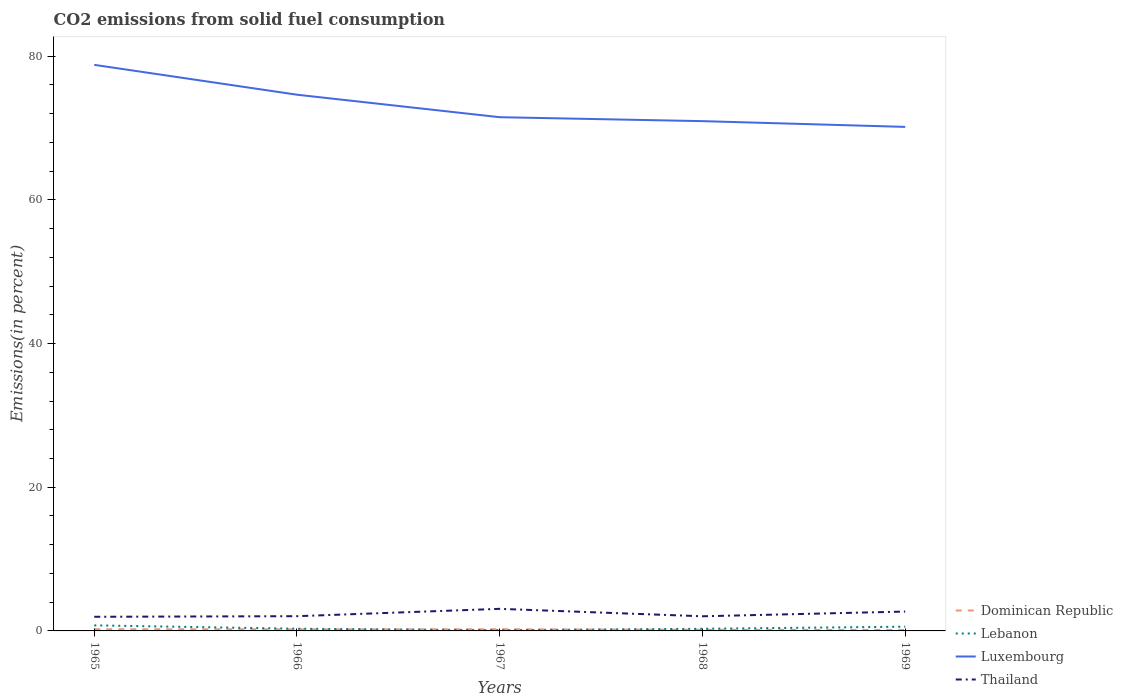How many different coloured lines are there?
Your answer should be compact. 4. Does the line corresponding to Dominican Republic intersect with the line corresponding to Luxembourg?
Make the answer very short. No. Is the number of lines equal to the number of legend labels?
Provide a succinct answer. Yes. Across all years, what is the maximum total CO2 emitted in Lebanon?
Keep it short and to the point. 0.1. In which year was the total CO2 emitted in Luxembourg maximum?
Give a very brief answer. 1969. What is the total total CO2 emitted in Dominican Republic in the graph?
Your answer should be compact. 0.08. What is the difference between the highest and the second highest total CO2 emitted in Dominican Republic?
Your answer should be compact. 0.1. What is the difference between the highest and the lowest total CO2 emitted in Thailand?
Provide a short and direct response. 2. Is the total CO2 emitted in Lebanon strictly greater than the total CO2 emitted in Luxembourg over the years?
Keep it short and to the point. Yes. How many years are there in the graph?
Provide a succinct answer. 5. Does the graph contain any zero values?
Offer a terse response. No. Does the graph contain grids?
Keep it short and to the point. No. Where does the legend appear in the graph?
Offer a very short reply. Bottom right. How are the legend labels stacked?
Ensure brevity in your answer.  Vertical. What is the title of the graph?
Your response must be concise. CO2 emissions from solid fuel consumption. What is the label or title of the X-axis?
Provide a succinct answer. Years. What is the label or title of the Y-axis?
Provide a succinct answer. Emissions(in percent). What is the Emissions(in percent) of Dominican Republic in 1965?
Make the answer very short. 0.24. What is the Emissions(in percent) of Lebanon in 1965?
Give a very brief answer. 0.77. What is the Emissions(in percent) of Luxembourg in 1965?
Keep it short and to the point. 78.79. What is the Emissions(in percent) in Thailand in 1965?
Provide a succinct answer. 1.97. What is the Emissions(in percent) of Dominican Republic in 1966?
Offer a very short reply. 0.22. What is the Emissions(in percent) of Lebanon in 1966?
Your answer should be very brief. 0.3. What is the Emissions(in percent) of Luxembourg in 1966?
Your answer should be compact. 74.63. What is the Emissions(in percent) in Thailand in 1966?
Your answer should be very brief. 2.05. What is the Emissions(in percent) of Dominican Republic in 1967?
Provide a succinct answer. 0.23. What is the Emissions(in percent) in Lebanon in 1967?
Your response must be concise. 0.1. What is the Emissions(in percent) of Luxembourg in 1967?
Offer a very short reply. 71.5. What is the Emissions(in percent) of Thailand in 1967?
Offer a very short reply. 3.07. What is the Emissions(in percent) in Dominican Republic in 1968?
Your response must be concise. 0.16. What is the Emissions(in percent) of Lebanon in 1968?
Make the answer very short. 0.3. What is the Emissions(in percent) in Luxembourg in 1968?
Offer a terse response. 70.95. What is the Emissions(in percent) of Thailand in 1968?
Provide a short and direct response. 2.04. What is the Emissions(in percent) of Dominican Republic in 1969?
Give a very brief answer. 0.14. What is the Emissions(in percent) in Lebanon in 1969?
Your answer should be very brief. 0.59. What is the Emissions(in percent) in Luxembourg in 1969?
Provide a succinct answer. 70.15. What is the Emissions(in percent) in Thailand in 1969?
Provide a succinct answer. 2.69. Across all years, what is the maximum Emissions(in percent) of Dominican Republic?
Your answer should be very brief. 0.24. Across all years, what is the maximum Emissions(in percent) of Lebanon?
Give a very brief answer. 0.77. Across all years, what is the maximum Emissions(in percent) in Luxembourg?
Make the answer very short. 78.79. Across all years, what is the maximum Emissions(in percent) in Thailand?
Offer a very short reply. 3.07. Across all years, what is the minimum Emissions(in percent) in Dominican Republic?
Your answer should be compact. 0.14. Across all years, what is the minimum Emissions(in percent) in Lebanon?
Ensure brevity in your answer.  0.1. Across all years, what is the minimum Emissions(in percent) of Luxembourg?
Your response must be concise. 70.15. Across all years, what is the minimum Emissions(in percent) of Thailand?
Provide a short and direct response. 1.97. What is the total Emissions(in percent) in Dominican Republic in the graph?
Provide a succinct answer. 0.98. What is the total Emissions(in percent) in Lebanon in the graph?
Your response must be concise. 2.07. What is the total Emissions(in percent) in Luxembourg in the graph?
Your answer should be compact. 366.01. What is the total Emissions(in percent) of Thailand in the graph?
Provide a short and direct response. 11.82. What is the difference between the Emissions(in percent) of Dominican Republic in 1965 and that in 1966?
Your response must be concise. 0.02. What is the difference between the Emissions(in percent) of Lebanon in 1965 and that in 1966?
Give a very brief answer. 0.47. What is the difference between the Emissions(in percent) in Luxembourg in 1965 and that in 1966?
Provide a succinct answer. 4.16. What is the difference between the Emissions(in percent) in Thailand in 1965 and that in 1966?
Ensure brevity in your answer.  -0.08. What is the difference between the Emissions(in percent) of Dominican Republic in 1965 and that in 1967?
Offer a very short reply. 0. What is the difference between the Emissions(in percent) in Lebanon in 1965 and that in 1967?
Provide a short and direct response. 0.67. What is the difference between the Emissions(in percent) of Luxembourg in 1965 and that in 1967?
Offer a terse response. 7.29. What is the difference between the Emissions(in percent) of Thailand in 1965 and that in 1967?
Give a very brief answer. -1.11. What is the difference between the Emissions(in percent) in Dominican Republic in 1965 and that in 1968?
Ensure brevity in your answer.  0.08. What is the difference between the Emissions(in percent) of Lebanon in 1965 and that in 1968?
Give a very brief answer. 0.48. What is the difference between the Emissions(in percent) of Luxembourg in 1965 and that in 1968?
Provide a short and direct response. 7.84. What is the difference between the Emissions(in percent) in Thailand in 1965 and that in 1968?
Make the answer very short. -0.07. What is the difference between the Emissions(in percent) in Dominican Republic in 1965 and that in 1969?
Ensure brevity in your answer.  0.1. What is the difference between the Emissions(in percent) of Lebanon in 1965 and that in 1969?
Give a very brief answer. 0.18. What is the difference between the Emissions(in percent) of Luxembourg in 1965 and that in 1969?
Offer a terse response. 8.64. What is the difference between the Emissions(in percent) of Thailand in 1965 and that in 1969?
Provide a succinct answer. -0.73. What is the difference between the Emissions(in percent) of Dominican Republic in 1966 and that in 1967?
Your answer should be compact. -0.01. What is the difference between the Emissions(in percent) in Lebanon in 1966 and that in 1967?
Offer a terse response. 0.2. What is the difference between the Emissions(in percent) of Luxembourg in 1966 and that in 1967?
Provide a succinct answer. 3.13. What is the difference between the Emissions(in percent) of Thailand in 1966 and that in 1967?
Your answer should be compact. -1.02. What is the difference between the Emissions(in percent) in Dominican Republic in 1966 and that in 1968?
Offer a very short reply. 0.06. What is the difference between the Emissions(in percent) in Lebanon in 1966 and that in 1968?
Your answer should be very brief. 0.01. What is the difference between the Emissions(in percent) in Luxembourg in 1966 and that in 1968?
Your answer should be compact. 3.68. What is the difference between the Emissions(in percent) of Thailand in 1966 and that in 1968?
Your answer should be compact. 0.01. What is the difference between the Emissions(in percent) of Dominican Republic in 1966 and that in 1969?
Provide a succinct answer. 0.08. What is the difference between the Emissions(in percent) of Lebanon in 1966 and that in 1969?
Make the answer very short. -0.29. What is the difference between the Emissions(in percent) in Luxembourg in 1966 and that in 1969?
Make the answer very short. 4.48. What is the difference between the Emissions(in percent) of Thailand in 1966 and that in 1969?
Your answer should be compact. -0.64. What is the difference between the Emissions(in percent) of Dominican Republic in 1967 and that in 1968?
Your answer should be compact. 0.08. What is the difference between the Emissions(in percent) in Lebanon in 1967 and that in 1968?
Offer a very short reply. -0.19. What is the difference between the Emissions(in percent) of Luxembourg in 1967 and that in 1968?
Keep it short and to the point. 0.55. What is the difference between the Emissions(in percent) in Thailand in 1967 and that in 1968?
Give a very brief answer. 1.04. What is the difference between the Emissions(in percent) in Dominican Republic in 1967 and that in 1969?
Give a very brief answer. 0.1. What is the difference between the Emissions(in percent) of Lebanon in 1967 and that in 1969?
Offer a terse response. -0.49. What is the difference between the Emissions(in percent) in Luxembourg in 1967 and that in 1969?
Ensure brevity in your answer.  1.35. What is the difference between the Emissions(in percent) in Thailand in 1967 and that in 1969?
Provide a short and direct response. 0.38. What is the difference between the Emissions(in percent) of Dominican Republic in 1968 and that in 1969?
Your response must be concise. 0.02. What is the difference between the Emissions(in percent) in Lebanon in 1968 and that in 1969?
Keep it short and to the point. -0.29. What is the difference between the Emissions(in percent) in Luxembourg in 1968 and that in 1969?
Keep it short and to the point. 0.8. What is the difference between the Emissions(in percent) in Thailand in 1968 and that in 1969?
Give a very brief answer. -0.66. What is the difference between the Emissions(in percent) of Dominican Republic in 1965 and the Emissions(in percent) of Lebanon in 1966?
Offer a very short reply. -0.07. What is the difference between the Emissions(in percent) in Dominican Republic in 1965 and the Emissions(in percent) in Luxembourg in 1966?
Offer a terse response. -74.39. What is the difference between the Emissions(in percent) in Dominican Republic in 1965 and the Emissions(in percent) in Thailand in 1966?
Your response must be concise. -1.81. What is the difference between the Emissions(in percent) in Lebanon in 1965 and the Emissions(in percent) in Luxembourg in 1966?
Keep it short and to the point. -73.86. What is the difference between the Emissions(in percent) in Lebanon in 1965 and the Emissions(in percent) in Thailand in 1966?
Your response must be concise. -1.28. What is the difference between the Emissions(in percent) in Luxembourg in 1965 and the Emissions(in percent) in Thailand in 1966?
Ensure brevity in your answer.  76.74. What is the difference between the Emissions(in percent) in Dominican Republic in 1965 and the Emissions(in percent) in Lebanon in 1967?
Ensure brevity in your answer.  0.13. What is the difference between the Emissions(in percent) of Dominican Republic in 1965 and the Emissions(in percent) of Luxembourg in 1967?
Make the answer very short. -71.26. What is the difference between the Emissions(in percent) of Dominican Republic in 1965 and the Emissions(in percent) of Thailand in 1967?
Your response must be concise. -2.84. What is the difference between the Emissions(in percent) in Lebanon in 1965 and the Emissions(in percent) in Luxembourg in 1967?
Provide a succinct answer. -70.72. What is the difference between the Emissions(in percent) of Lebanon in 1965 and the Emissions(in percent) of Thailand in 1967?
Your answer should be compact. -2.3. What is the difference between the Emissions(in percent) in Luxembourg in 1965 and the Emissions(in percent) in Thailand in 1967?
Offer a terse response. 75.71. What is the difference between the Emissions(in percent) of Dominican Republic in 1965 and the Emissions(in percent) of Lebanon in 1968?
Your answer should be very brief. -0.06. What is the difference between the Emissions(in percent) of Dominican Republic in 1965 and the Emissions(in percent) of Luxembourg in 1968?
Keep it short and to the point. -70.71. What is the difference between the Emissions(in percent) in Dominican Republic in 1965 and the Emissions(in percent) in Thailand in 1968?
Your answer should be very brief. -1.8. What is the difference between the Emissions(in percent) of Lebanon in 1965 and the Emissions(in percent) of Luxembourg in 1968?
Give a very brief answer. -70.18. What is the difference between the Emissions(in percent) in Lebanon in 1965 and the Emissions(in percent) in Thailand in 1968?
Make the answer very short. -1.26. What is the difference between the Emissions(in percent) of Luxembourg in 1965 and the Emissions(in percent) of Thailand in 1968?
Your response must be concise. 76.75. What is the difference between the Emissions(in percent) of Dominican Republic in 1965 and the Emissions(in percent) of Lebanon in 1969?
Offer a very short reply. -0.35. What is the difference between the Emissions(in percent) in Dominican Republic in 1965 and the Emissions(in percent) in Luxembourg in 1969?
Keep it short and to the point. -69.91. What is the difference between the Emissions(in percent) in Dominican Republic in 1965 and the Emissions(in percent) in Thailand in 1969?
Provide a short and direct response. -2.46. What is the difference between the Emissions(in percent) in Lebanon in 1965 and the Emissions(in percent) in Luxembourg in 1969?
Keep it short and to the point. -69.38. What is the difference between the Emissions(in percent) of Lebanon in 1965 and the Emissions(in percent) of Thailand in 1969?
Make the answer very short. -1.92. What is the difference between the Emissions(in percent) of Luxembourg in 1965 and the Emissions(in percent) of Thailand in 1969?
Give a very brief answer. 76.09. What is the difference between the Emissions(in percent) of Dominican Republic in 1966 and the Emissions(in percent) of Lebanon in 1967?
Your answer should be very brief. 0.12. What is the difference between the Emissions(in percent) in Dominican Republic in 1966 and the Emissions(in percent) in Luxembourg in 1967?
Give a very brief answer. -71.28. What is the difference between the Emissions(in percent) in Dominican Republic in 1966 and the Emissions(in percent) in Thailand in 1967?
Offer a terse response. -2.85. What is the difference between the Emissions(in percent) in Lebanon in 1966 and the Emissions(in percent) in Luxembourg in 1967?
Ensure brevity in your answer.  -71.19. What is the difference between the Emissions(in percent) in Lebanon in 1966 and the Emissions(in percent) in Thailand in 1967?
Offer a terse response. -2.77. What is the difference between the Emissions(in percent) in Luxembourg in 1966 and the Emissions(in percent) in Thailand in 1967?
Give a very brief answer. 71.56. What is the difference between the Emissions(in percent) of Dominican Republic in 1966 and the Emissions(in percent) of Lebanon in 1968?
Offer a terse response. -0.08. What is the difference between the Emissions(in percent) in Dominican Republic in 1966 and the Emissions(in percent) in Luxembourg in 1968?
Your response must be concise. -70.73. What is the difference between the Emissions(in percent) in Dominican Republic in 1966 and the Emissions(in percent) in Thailand in 1968?
Your answer should be compact. -1.82. What is the difference between the Emissions(in percent) in Lebanon in 1966 and the Emissions(in percent) in Luxembourg in 1968?
Ensure brevity in your answer.  -70.65. What is the difference between the Emissions(in percent) in Lebanon in 1966 and the Emissions(in percent) in Thailand in 1968?
Offer a very short reply. -1.73. What is the difference between the Emissions(in percent) in Luxembourg in 1966 and the Emissions(in percent) in Thailand in 1968?
Your response must be concise. 72.59. What is the difference between the Emissions(in percent) in Dominican Republic in 1966 and the Emissions(in percent) in Lebanon in 1969?
Your answer should be compact. -0.37. What is the difference between the Emissions(in percent) in Dominican Republic in 1966 and the Emissions(in percent) in Luxembourg in 1969?
Offer a terse response. -69.93. What is the difference between the Emissions(in percent) in Dominican Republic in 1966 and the Emissions(in percent) in Thailand in 1969?
Provide a short and direct response. -2.48. What is the difference between the Emissions(in percent) of Lebanon in 1966 and the Emissions(in percent) of Luxembourg in 1969?
Your response must be concise. -69.85. What is the difference between the Emissions(in percent) of Lebanon in 1966 and the Emissions(in percent) of Thailand in 1969?
Make the answer very short. -2.39. What is the difference between the Emissions(in percent) of Luxembourg in 1966 and the Emissions(in percent) of Thailand in 1969?
Offer a terse response. 71.93. What is the difference between the Emissions(in percent) of Dominican Republic in 1967 and the Emissions(in percent) of Lebanon in 1968?
Give a very brief answer. -0.06. What is the difference between the Emissions(in percent) in Dominican Republic in 1967 and the Emissions(in percent) in Luxembourg in 1968?
Provide a short and direct response. -70.72. What is the difference between the Emissions(in percent) in Dominican Republic in 1967 and the Emissions(in percent) in Thailand in 1968?
Your response must be concise. -1.8. What is the difference between the Emissions(in percent) in Lebanon in 1967 and the Emissions(in percent) in Luxembourg in 1968?
Your answer should be compact. -70.85. What is the difference between the Emissions(in percent) of Lebanon in 1967 and the Emissions(in percent) of Thailand in 1968?
Give a very brief answer. -1.93. What is the difference between the Emissions(in percent) in Luxembourg in 1967 and the Emissions(in percent) in Thailand in 1968?
Give a very brief answer. 69.46. What is the difference between the Emissions(in percent) of Dominican Republic in 1967 and the Emissions(in percent) of Lebanon in 1969?
Your response must be concise. -0.36. What is the difference between the Emissions(in percent) in Dominican Republic in 1967 and the Emissions(in percent) in Luxembourg in 1969?
Make the answer very short. -69.92. What is the difference between the Emissions(in percent) of Dominican Republic in 1967 and the Emissions(in percent) of Thailand in 1969?
Give a very brief answer. -2.46. What is the difference between the Emissions(in percent) in Lebanon in 1967 and the Emissions(in percent) in Luxembourg in 1969?
Offer a very short reply. -70.05. What is the difference between the Emissions(in percent) in Lebanon in 1967 and the Emissions(in percent) in Thailand in 1969?
Your answer should be compact. -2.59. What is the difference between the Emissions(in percent) in Luxembourg in 1967 and the Emissions(in percent) in Thailand in 1969?
Offer a very short reply. 68.8. What is the difference between the Emissions(in percent) of Dominican Republic in 1968 and the Emissions(in percent) of Lebanon in 1969?
Provide a succinct answer. -0.43. What is the difference between the Emissions(in percent) of Dominican Republic in 1968 and the Emissions(in percent) of Luxembourg in 1969?
Provide a short and direct response. -69.99. What is the difference between the Emissions(in percent) of Dominican Republic in 1968 and the Emissions(in percent) of Thailand in 1969?
Make the answer very short. -2.54. What is the difference between the Emissions(in percent) of Lebanon in 1968 and the Emissions(in percent) of Luxembourg in 1969?
Your response must be concise. -69.85. What is the difference between the Emissions(in percent) in Lebanon in 1968 and the Emissions(in percent) in Thailand in 1969?
Ensure brevity in your answer.  -2.4. What is the difference between the Emissions(in percent) of Luxembourg in 1968 and the Emissions(in percent) of Thailand in 1969?
Your answer should be compact. 68.26. What is the average Emissions(in percent) in Dominican Republic per year?
Offer a terse response. 0.2. What is the average Emissions(in percent) of Lebanon per year?
Offer a very short reply. 0.41. What is the average Emissions(in percent) of Luxembourg per year?
Make the answer very short. 73.2. What is the average Emissions(in percent) in Thailand per year?
Your answer should be very brief. 2.37. In the year 1965, what is the difference between the Emissions(in percent) of Dominican Republic and Emissions(in percent) of Lebanon?
Provide a short and direct response. -0.54. In the year 1965, what is the difference between the Emissions(in percent) of Dominican Republic and Emissions(in percent) of Luxembourg?
Your answer should be compact. -78.55. In the year 1965, what is the difference between the Emissions(in percent) of Dominican Republic and Emissions(in percent) of Thailand?
Your answer should be compact. -1.73. In the year 1965, what is the difference between the Emissions(in percent) in Lebanon and Emissions(in percent) in Luxembourg?
Keep it short and to the point. -78.01. In the year 1965, what is the difference between the Emissions(in percent) in Lebanon and Emissions(in percent) in Thailand?
Your response must be concise. -1.2. In the year 1965, what is the difference between the Emissions(in percent) of Luxembourg and Emissions(in percent) of Thailand?
Keep it short and to the point. 76.82. In the year 1966, what is the difference between the Emissions(in percent) of Dominican Republic and Emissions(in percent) of Lebanon?
Your answer should be compact. -0.08. In the year 1966, what is the difference between the Emissions(in percent) of Dominican Republic and Emissions(in percent) of Luxembourg?
Offer a very short reply. -74.41. In the year 1966, what is the difference between the Emissions(in percent) of Dominican Republic and Emissions(in percent) of Thailand?
Ensure brevity in your answer.  -1.83. In the year 1966, what is the difference between the Emissions(in percent) of Lebanon and Emissions(in percent) of Luxembourg?
Make the answer very short. -74.33. In the year 1966, what is the difference between the Emissions(in percent) in Lebanon and Emissions(in percent) in Thailand?
Ensure brevity in your answer.  -1.75. In the year 1966, what is the difference between the Emissions(in percent) in Luxembourg and Emissions(in percent) in Thailand?
Make the answer very short. 72.58. In the year 1967, what is the difference between the Emissions(in percent) in Dominican Republic and Emissions(in percent) in Lebanon?
Give a very brief answer. 0.13. In the year 1967, what is the difference between the Emissions(in percent) of Dominican Republic and Emissions(in percent) of Luxembourg?
Keep it short and to the point. -71.26. In the year 1967, what is the difference between the Emissions(in percent) in Dominican Republic and Emissions(in percent) in Thailand?
Offer a terse response. -2.84. In the year 1967, what is the difference between the Emissions(in percent) of Lebanon and Emissions(in percent) of Luxembourg?
Offer a very short reply. -71.4. In the year 1967, what is the difference between the Emissions(in percent) in Lebanon and Emissions(in percent) in Thailand?
Your answer should be compact. -2.97. In the year 1967, what is the difference between the Emissions(in percent) in Luxembourg and Emissions(in percent) in Thailand?
Provide a succinct answer. 68.42. In the year 1968, what is the difference between the Emissions(in percent) in Dominican Republic and Emissions(in percent) in Lebanon?
Keep it short and to the point. -0.14. In the year 1968, what is the difference between the Emissions(in percent) in Dominican Republic and Emissions(in percent) in Luxembourg?
Keep it short and to the point. -70.79. In the year 1968, what is the difference between the Emissions(in percent) in Dominican Republic and Emissions(in percent) in Thailand?
Give a very brief answer. -1.88. In the year 1968, what is the difference between the Emissions(in percent) in Lebanon and Emissions(in percent) in Luxembourg?
Your answer should be compact. -70.65. In the year 1968, what is the difference between the Emissions(in percent) of Lebanon and Emissions(in percent) of Thailand?
Offer a terse response. -1.74. In the year 1968, what is the difference between the Emissions(in percent) in Luxembourg and Emissions(in percent) in Thailand?
Give a very brief answer. 68.91. In the year 1969, what is the difference between the Emissions(in percent) of Dominican Republic and Emissions(in percent) of Lebanon?
Give a very brief answer. -0.45. In the year 1969, what is the difference between the Emissions(in percent) in Dominican Republic and Emissions(in percent) in Luxembourg?
Provide a short and direct response. -70.01. In the year 1969, what is the difference between the Emissions(in percent) in Dominican Republic and Emissions(in percent) in Thailand?
Your response must be concise. -2.56. In the year 1969, what is the difference between the Emissions(in percent) of Lebanon and Emissions(in percent) of Luxembourg?
Your answer should be very brief. -69.56. In the year 1969, what is the difference between the Emissions(in percent) in Lebanon and Emissions(in percent) in Thailand?
Offer a very short reply. -2.1. In the year 1969, what is the difference between the Emissions(in percent) in Luxembourg and Emissions(in percent) in Thailand?
Give a very brief answer. 67.46. What is the ratio of the Emissions(in percent) in Dominican Republic in 1965 to that in 1966?
Give a very brief answer. 1.08. What is the ratio of the Emissions(in percent) in Lebanon in 1965 to that in 1966?
Offer a very short reply. 2.55. What is the ratio of the Emissions(in percent) of Luxembourg in 1965 to that in 1966?
Your answer should be very brief. 1.06. What is the ratio of the Emissions(in percent) of Thailand in 1965 to that in 1966?
Your answer should be compact. 0.96. What is the ratio of the Emissions(in percent) in Dominican Republic in 1965 to that in 1967?
Provide a succinct answer. 1.01. What is the ratio of the Emissions(in percent) of Lebanon in 1965 to that in 1967?
Ensure brevity in your answer.  7.53. What is the ratio of the Emissions(in percent) in Luxembourg in 1965 to that in 1967?
Keep it short and to the point. 1.1. What is the ratio of the Emissions(in percent) of Thailand in 1965 to that in 1967?
Offer a terse response. 0.64. What is the ratio of the Emissions(in percent) in Dominican Republic in 1965 to that in 1968?
Offer a terse response. 1.52. What is the ratio of the Emissions(in percent) of Lebanon in 1965 to that in 1968?
Ensure brevity in your answer.  2.6. What is the ratio of the Emissions(in percent) in Luxembourg in 1965 to that in 1968?
Ensure brevity in your answer.  1.11. What is the ratio of the Emissions(in percent) in Thailand in 1965 to that in 1968?
Offer a very short reply. 0.97. What is the ratio of the Emissions(in percent) of Dominican Republic in 1965 to that in 1969?
Keep it short and to the point. 1.72. What is the ratio of the Emissions(in percent) of Lebanon in 1965 to that in 1969?
Provide a succinct answer. 1.31. What is the ratio of the Emissions(in percent) of Luxembourg in 1965 to that in 1969?
Provide a succinct answer. 1.12. What is the ratio of the Emissions(in percent) of Thailand in 1965 to that in 1969?
Provide a succinct answer. 0.73. What is the ratio of the Emissions(in percent) of Dominican Republic in 1966 to that in 1967?
Offer a very short reply. 0.94. What is the ratio of the Emissions(in percent) of Lebanon in 1966 to that in 1967?
Make the answer very short. 2.95. What is the ratio of the Emissions(in percent) in Luxembourg in 1966 to that in 1967?
Give a very brief answer. 1.04. What is the ratio of the Emissions(in percent) of Thailand in 1966 to that in 1967?
Your response must be concise. 0.67. What is the ratio of the Emissions(in percent) in Dominican Republic in 1966 to that in 1968?
Offer a very short reply. 1.41. What is the ratio of the Emissions(in percent) of Lebanon in 1966 to that in 1968?
Offer a terse response. 1.02. What is the ratio of the Emissions(in percent) of Luxembourg in 1966 to that in 1968?
Ensure brevity in your answer.  1.05. What is the ratio of the Emissions(in percent) in Thailand in 1966 to that in 1968?
Your response must be concise. 1.01. What is the ratio of the Emissions(in percent) of Dominican Republic in 1966 to that in 1969?
Your response must be concise. 1.59. What is the ratio of the Emissions(in percent) in Lebanon in 1966 to that in 1969?
Keep it short and to the point. 0.51. What is the ratio of the Emissions(in percent) of Luxembourg in 1966 to that in 1969?
Your answer should be compact. 1.06. What is the ratio of the Emissions(in percent) in Thailand in 1966 to that in 1969?
Your response must be concise. 0.76. What is the ratio of the Emissions(in percent) in Dominican Republic in 1967 to that in 1968?
Make the answer very short. 1.5. What is the ratio of the Emissions(in percent) in Lebanon in 1967 to that in 1968?
Provide a short and direct response. 0.35. What is the ratio of the Emissions(in percent) of Luxembourg in 1967 to that in 1968?
Offer a very short reply. 1.01. What is the ratio of the Emissions(in percent) of Thailand in 1967 to that in 1968?
Offer a terse response. 1.51. What is the ratio of the Emissions(in percent) in Dominican Republic in 1967 to that in 1969?
Make the answer very short. 1.69. What is the ratio of the Emissions(in percent) of Lebanon in 1967 to that in 1969?
Provide a short and direct response. 0.17. What is the ratio of the Emissions(in percent) in Luxembourg in 1967 to that in 1969?
Offer a terse response. 1.02. What is the ratio of the Emissions(in percent) of Thailand in 1967 to that in 1969?
Give a very brief answer. 1.14. What is the ratio of the Emissions(in percent) of Dominican Republic in 1968 to that in 1969?
Keep it short and to the point. 1.13. What is the ratio of the Emissions(in percent) in Lebanon in 1968 to that in 1969?
Make the answer very short. 0.5. What is the ratio of the Emissions(in percent) in Luxembourg in 1968 to that in 1969?
Offer a terse response. 1.01. What is the ratio of the Emissions(in percent) of Thailand in 1968 to that in 1969?
Make the answer very short. 0.76. What is the difference between the highest and the second highest Emissions(in percent) in Dominican Republic?
Make the answer very short. 0. What is the difference between the highest and the second highest Emissions(in percent) in Lebanon?
Keep it short and to the point. 0.18. What is the difference between the highest and the second highest Emissions(in percent) of Luxembourg?
Provide a succinct answer. 4.16. What is the difference between the highest and the second highest Emissions(in percent) of Thailand?
Keep it short and to the point. 0.38. What is the difference between the highest and the lowest Emissions(in percent) in Dominican Republic?
Your response must be concise. 0.1. What is the difference between the highest and the lowest Emissions(in percent) of Lebanon?
Offer a terse response. 0.67. What is the difference between the highest and the lowest Emissions(in percent) in Luxembourg?
Give a very brief answer. 8.64. What is the difference between the highest and the lowest Emissions(in percent) of Thailand?
Offer a terse response. 1.11. 